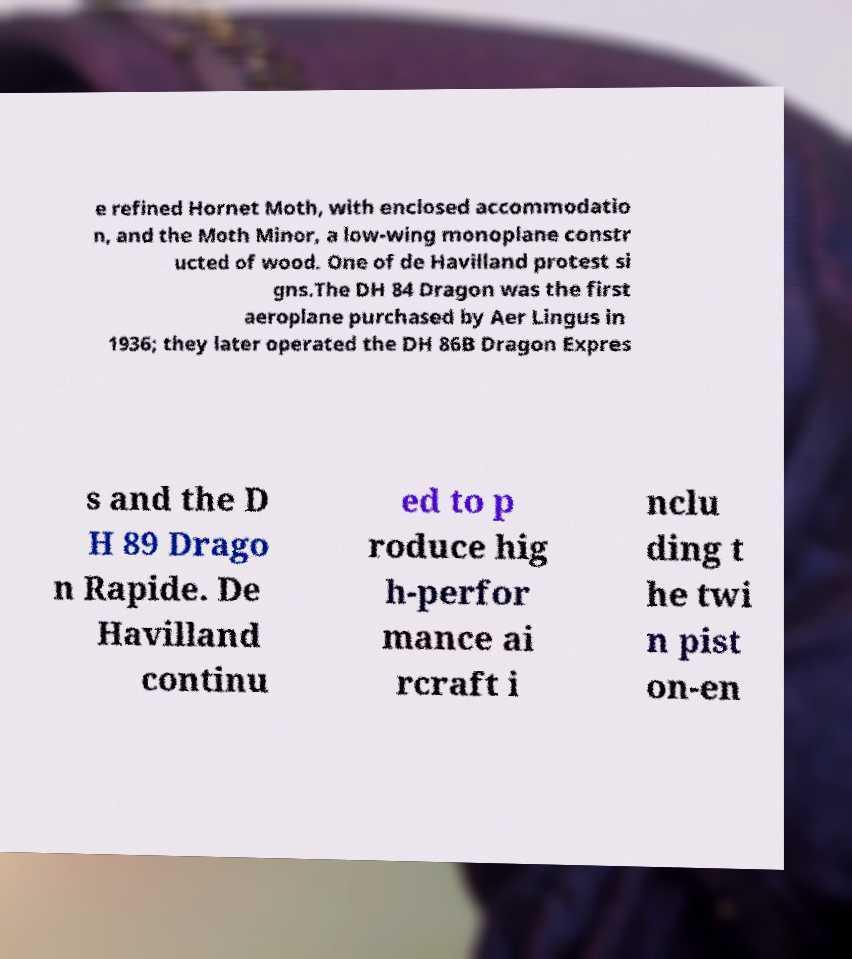I need the written content from this picture converted into text. Can you do that? e refined Hornet Moth, with enclosed accommodatio n, and the Moth Minor, a low-wing monoplane constr ucted of wood. One of de Havilland protest si gns.The DH 84 Dragon was the first aeroplane purchased by Aer Lingus in 1936; they later operated the DH 86B Dragon Expres s and the D H 89 Drago n Rapide. De Havilland continu ed to p roduce hig h-perfor mance ai rcraft i nclu ding t he twi n pist on-en 